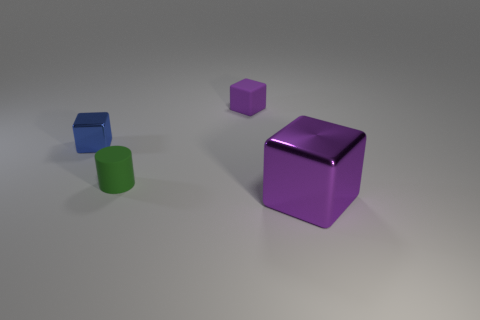What shape is the rubber object that is the same color as the large block?
Offer a very short reply. Cube. What number of shiny cubes have the same size as the matte cylinder?
Your response must be concise. 1. Do the big cube that is in front of the purple matte cube and the green cylinder have the same material?
Keep it short and to the point. No. Are any tiny matte cylinders visible?
Offer a very short reply. Yes. There is a cube that is the same material as the green cylinder; what is its size?
Offer a very short reply. Small. Is there another thing of the same color as the large shiny object?
Make the answer very short. Yes. There is a object in front of the green cylinder; is its color the same as the matte thing that is behind the small rubber cylinder?
Give a very brief answer. Yes. There is a shiny object that is the same color as the tiny rubber block; what size is it?
Offer a terse response. Large. Is there a tiny purple cube that has the same material as the cylinder?
Give a very brief answer. Yes. What is the color of the big metal object?
Offer a terse response. Purple. 